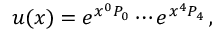<formula> <loc_0><loc_0><loc_500><loc_500>u ( x ) = e ^ { x ^ { 0 } P _ { 0 } } \cdots e ^ { x ^ { 4 } P _ { 4 } } \, ,</formula> 